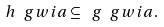Convert formula to latex. <formula><loc_0><loc_0><loc_500><loc_500>\ h \ g w i a \subseteq \ g \ g w i a .</formula> 